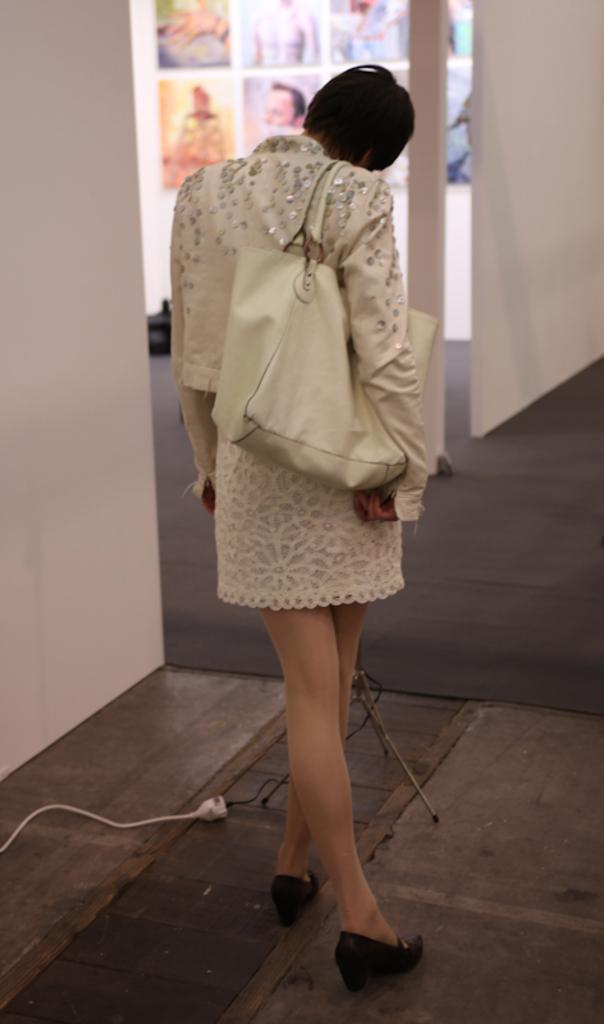What is the person in the image doing? The person is standing in the image. What is the person holding in the image? The person is holding a bag. What can be seen in the image besides the person? There is a stand in the image. What is visible in the background of the image? There are frames attached to the wall in the background of the image. What type of cracker is the person eating in the image? There is no cracker present in the image, and the person is not eating anything. 